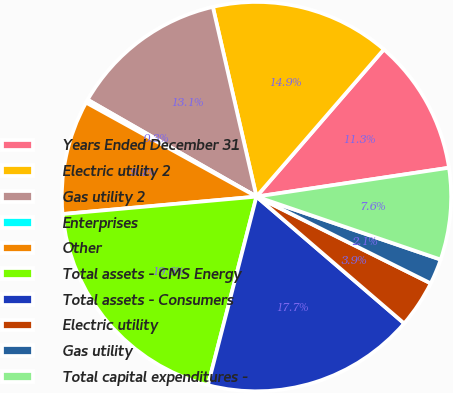<chart> <loc_0><loc_0><loc_500><loc_500><pie_chart><fcel>Years Ended December 31<fcel>Electric utility 2<fcel>Gas utility 2<fcel>Enterprises<fcel>Other<fcel>Total assets - CMS Energy<fcel>Total assets - Consumers<fcel>Electric utility<fcel>Gas utility<fcel>Total capital expenditures -<nl><fcel>11.28%<fcel>14.95%<fcel>13.11%<fcel>0.27%<fcel>9.45%<fcel>19.56%<fcel>17.72%<fcel>3.94%<fcel>2.11%<fcel>7.61%<nl></chart> 